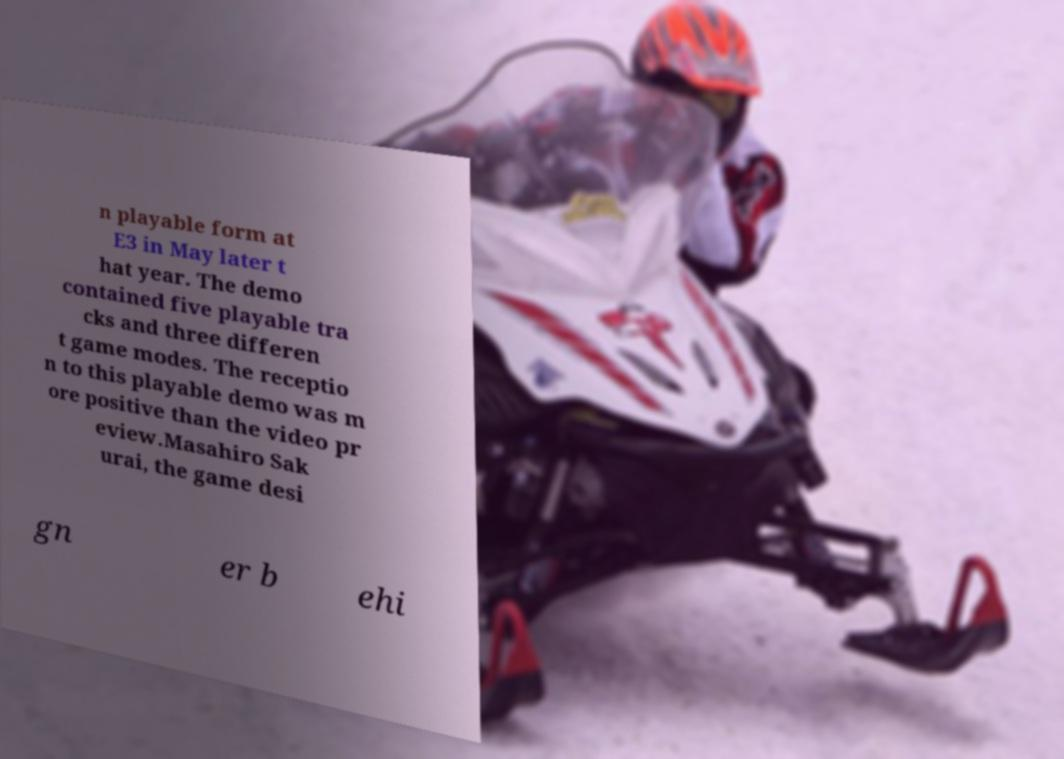Could you assist in decoding the text presented in this image and type it out clearly? n playable form at E3 in May later t hat year. The demo contained five playable tra cks and three differen t game modes. The receptio n to this playable demo was m ore positive than the video pr eview.Masahiro Sak urai, the game desi gn er b ehi 